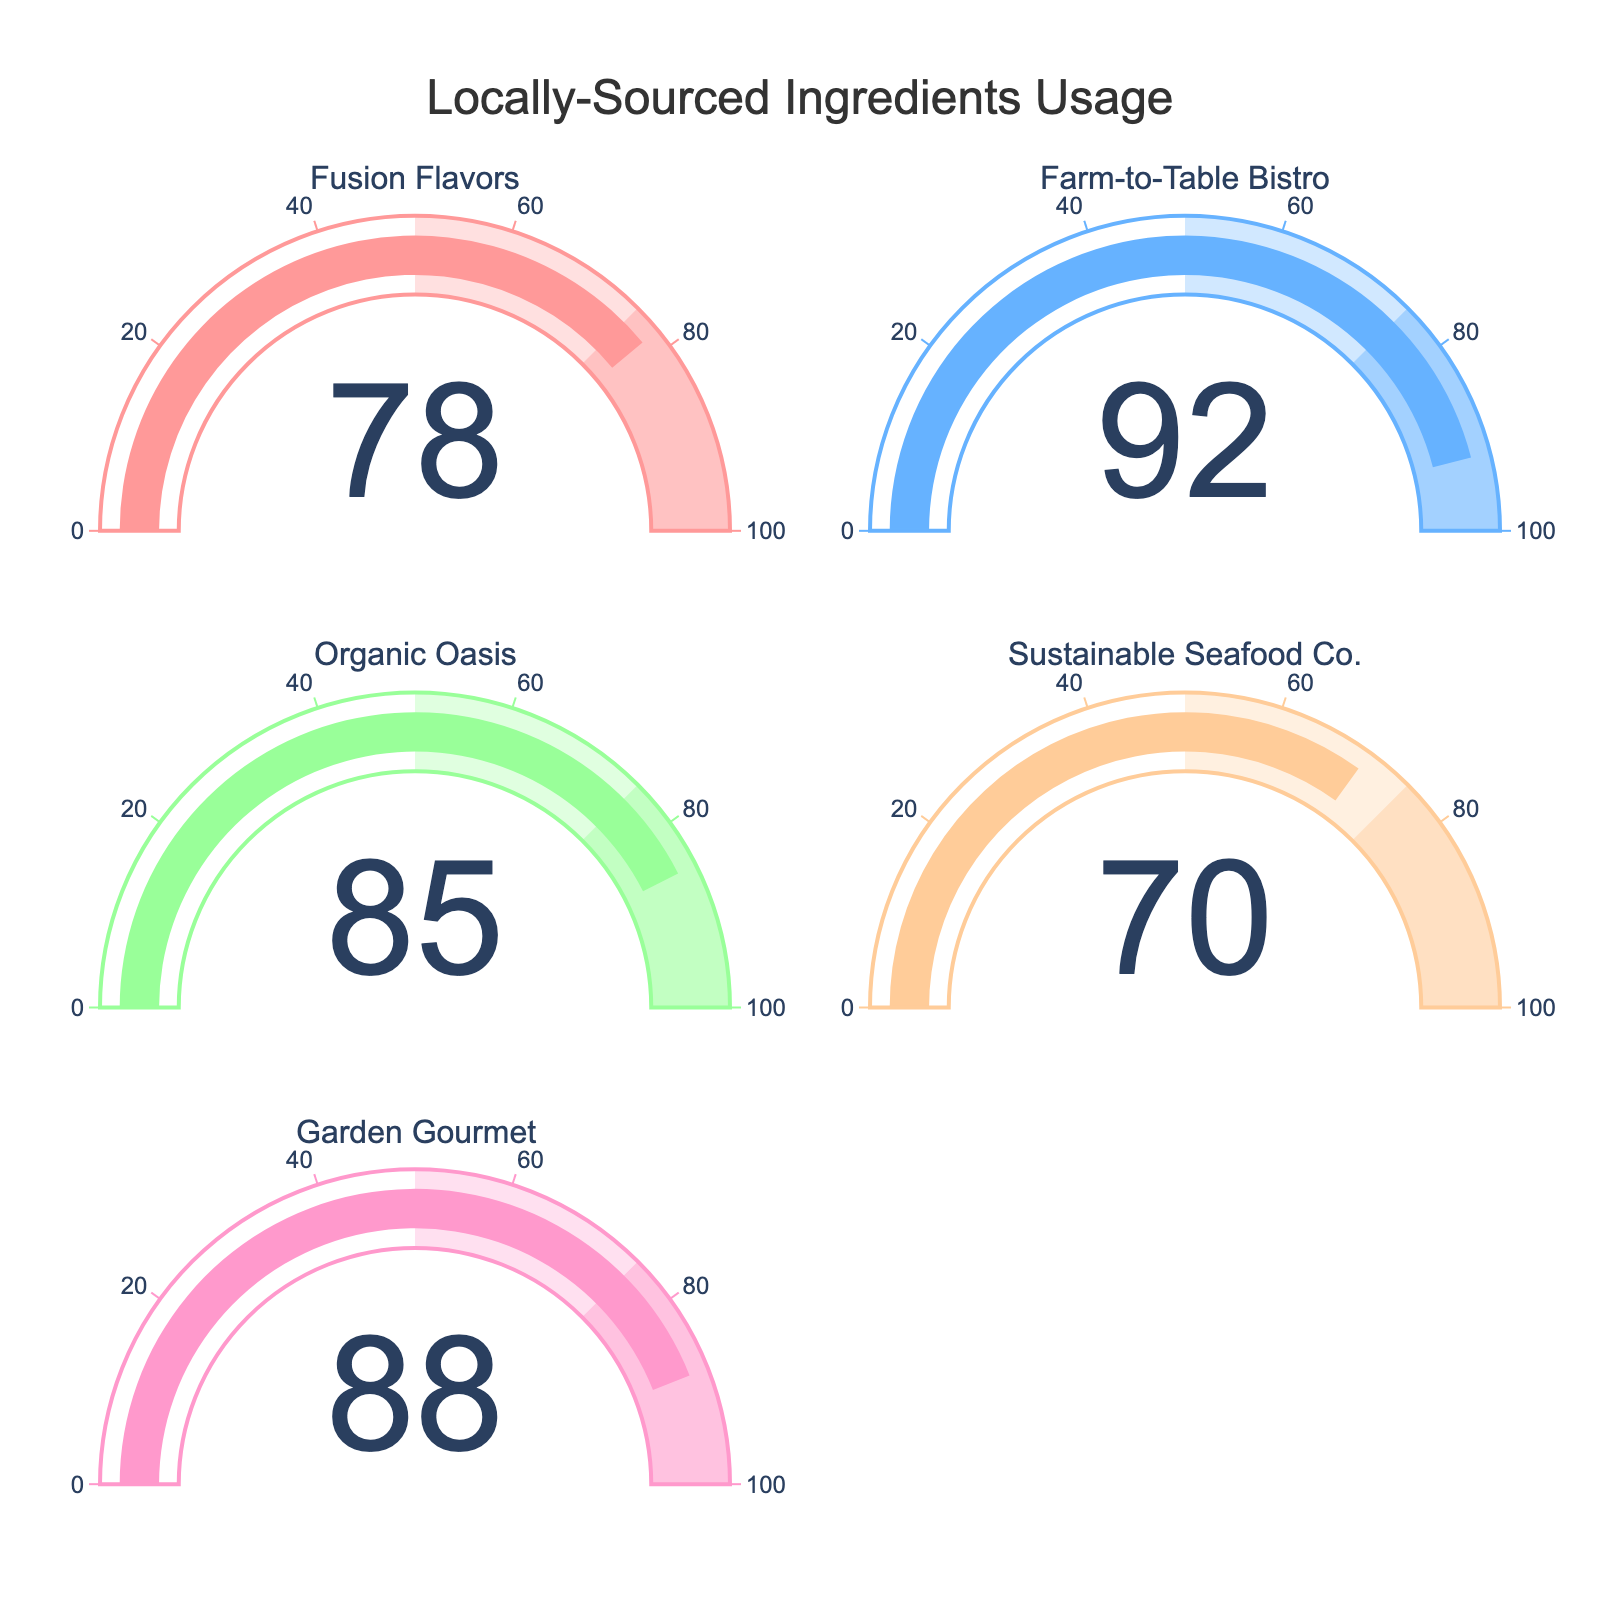What's the title of the figure? The title is typically located at the top center of the figure. By reading it, you can determine the main topic or purpose of the figure.
Answer: Locally-Sourced Ingredients Usage Which restaurant has the highest percentage of menu items using locally sourced ingredients? Look at each gauge chart and identify the one with the highest value shown.
Answer: Farm-to-Table Bistro What is the average percentage of menu items using locally sourced ingredients across all restaurants? First, add up all the percentages: 78 + 92 + 85 + 70 + 88 = 413. Then divide by the number of restaurants, which is 5. So, 413 / 5 = 82.6.
Answer: 82.6 How many restaurants have a locally sourced ingredient percentage above 80%? Count the number of gauges where the value is greater than 80.
Answer: 4 Which restaurant has the lowest percentage of menu items using locally sourced ingredients? Look at each gauge chart and identify the one with the lowest value shown.
Answer: Sustainable Seafood Co Is the percentage of menu items using locally sourced ingredients higher at Organic Oasis or Garden Gourmet? Compare the values on the gauges for Organic Oasis and Garden Gourmet.
Answer: Garden Gourmet What is the median percentage of menu items using locally sourced ingredients? List the percentages: 70, 78, 85, 88, 92 and find the middle value. The median in this case, where the number of data points is odd, is the middle number in the sorted list.
Answer: 85 How far above the lowest value is the highest percentage of locally sourced ingredients? Identify the lowest value (70) and the highest value (92). Subtract the lowest value from the highest value: 92 - 70 = 22.
Answer: 22 Which color is used for the gauge corresponding to Organic Oasis? In the figure, each gauge has a different color. Identify the color linked with the gauge of Organic Oasis.
Answer: Light green If the combined percentages of Sustainable Seafood Co. and Fusion Flavors are compared against the total of the other three restaurants, which sum is higher? Calculate the sum for Sustainable Seafood Co. and Fusion Flavors: 70 + 78 = 148. Calculate the sum for the other three restaurants: 92 + 85 + 88 = 265. Compare 148 and 265.
Answer: The sum of the other three restaurants 